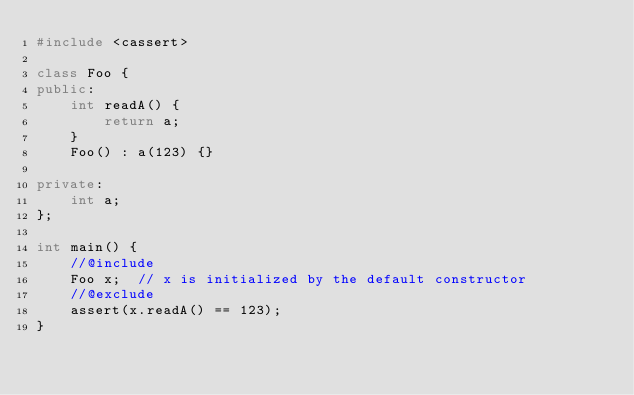<code> <loc_0><loc_0><loc_500><loc_500><_C++_>#include <cassert>

class Foo {
public:
    int readA() {
        return a;
    }
    Foo() : a(123) {}

private:
    int a;
};

int main() {
    //@include
    Foo x;  // x is initialized by the default constructor
    //@exclude
    assert(x.readA() == 123);
}
</code> 